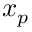<formula> <loc_0><loc_0><loc_500><loc_500>x _ { p }</formula> 